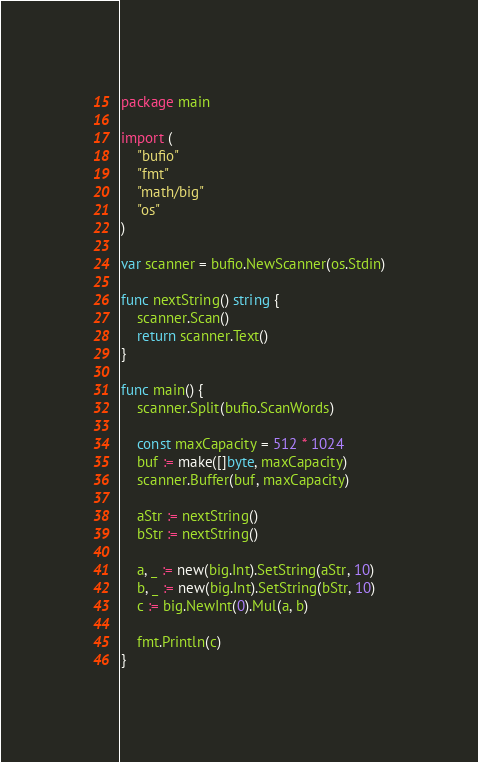<code> <loc_0><loc_0><loc_500><loc_500><_Go_>package main

import (
	"bufio"
	"fmt"
	"math/big"
	"os"
)

var scanner = bufio.NewScanner(os.Stdin)

func nextString() string {
	scanner.Scan()
	return scanner.Text()
}

func main() {
	scanner.Split(bufio.ScanWords)

	const maxCapacity = 512 * 1024
	buf := make([]byte, maxCapacity)
	scanner.Buffer(buf, maxCapacity)

	aStr := nextString()
	bStr := nextString()

	a, _ := new(big.Int).SetString(aStr, 10)
	b, _ := new(big.Int).SetString(bStr, 10)
	c := big.NewInt(0).Mul(a, b)

	fmt.Println(c)
}

</code> 